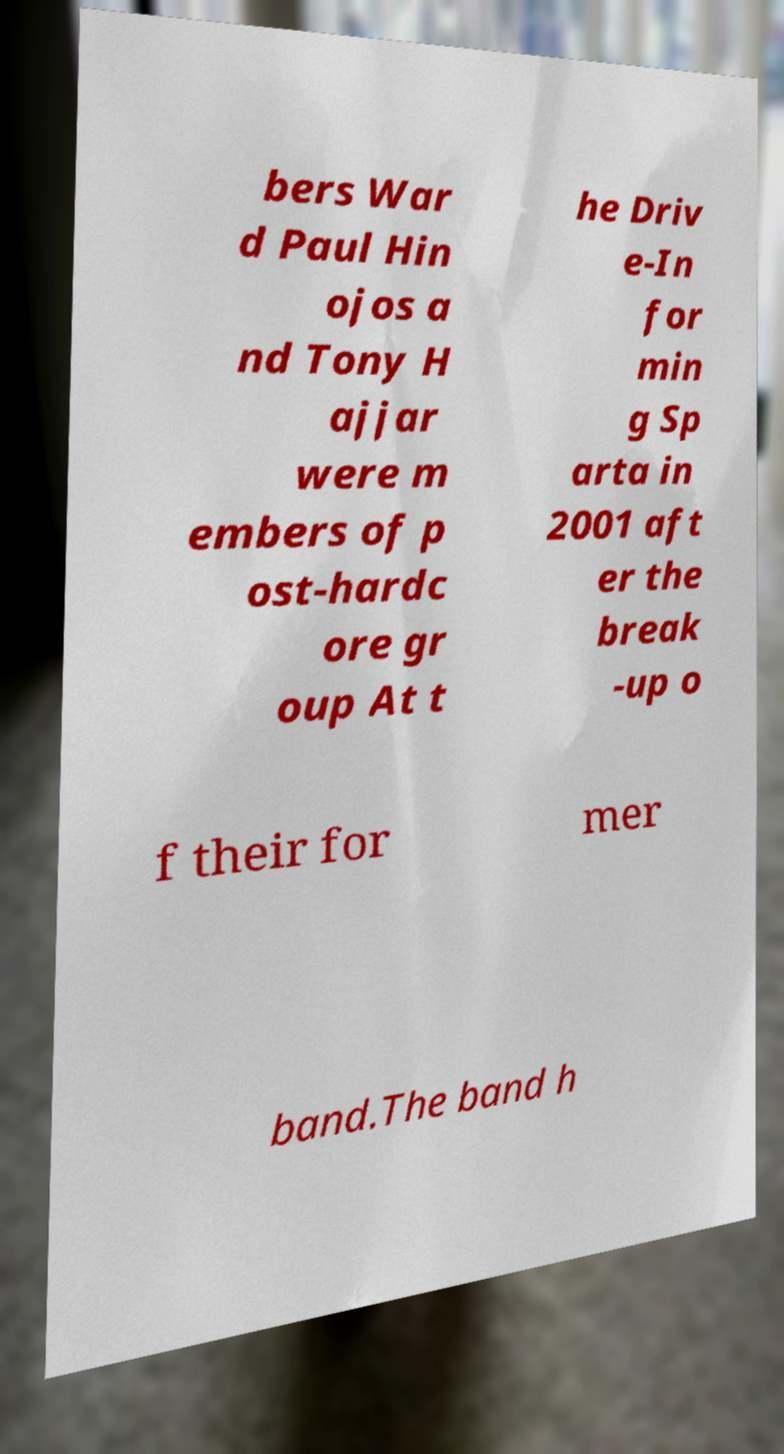Could you assist in decoding the text presented in this image and type it out clearly? bers War d Paul Hin ojos a nd Tony H ajjar were m embers of p ost-hardc ore gr oup At t he Driv e-In for min g Sp arta in 2001 aft er the break -up o f their for mer band.The band h 